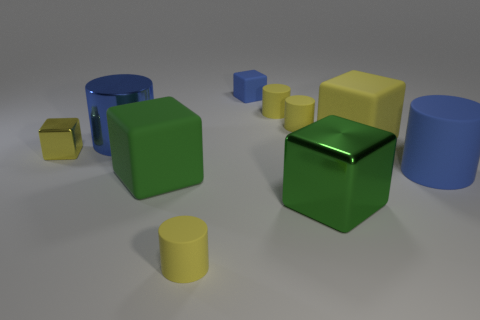Subtract all yellow blocks. How many yellow cylinders are left? 3 Subtract 2 cylinders. How many cylinders are left? 3 Subtract all blue cubes. How many cubes are left? 4 Subtract all big green rubber blocks. How many blocks are left? 4 Subtract all gray cylinders. Subtract all blue spheres. How many cylinders are left? 5 Subtract 0 purple cylinders. How many objects are left? 10 Subtract all large blue objects. Subtract all blue matte blocks. How many objects are left? 7 Add 7 blue matte cylinders. How many blue matte cylinders are left? 8 Add 5 big cyan metal cubes. How many big cyan metal cubes exist? 5 